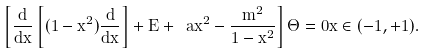Convert formula to latex. <formula><loc_0><loc_0><loc_500><loc_500>\left [ \frac { d } { d x } \left [ ( 1 - x ^ { 2 } ) \frac { d } { d x } \right ] + E + \ a x ^ { 2 } - \frac { m ^ { 2 } } { 1 - x ^ { 2 } } \right ] \Theta = 0 x \in ( - 1 , + 1 ) .</formula> 